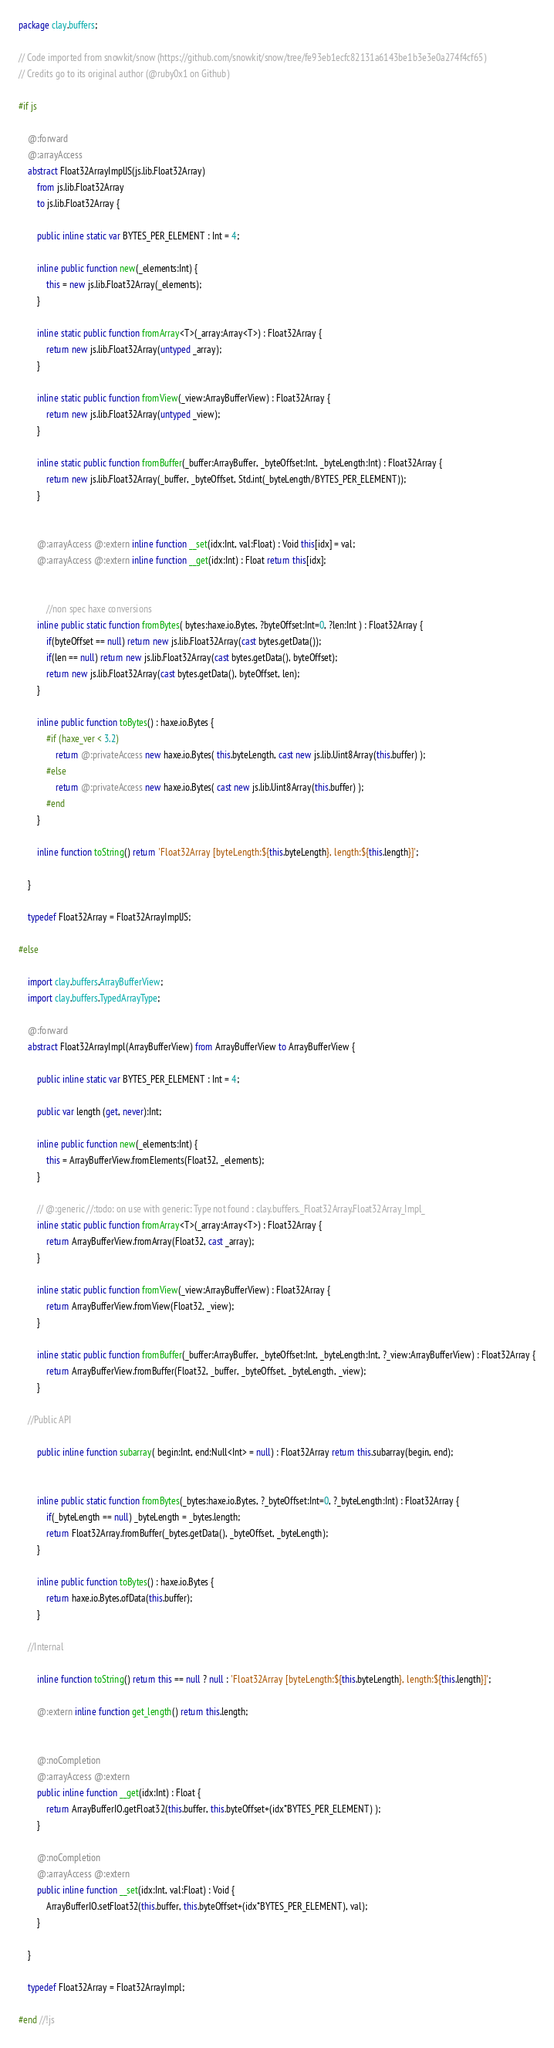<code> <loc_0><loc_0><loc_500><loc_500><_Haxe_>package clay.buffers;

// Code imported from snowkit/snow (https://github.com/snowkit/snow/tree/fe93eb1ecfc82131a6143be1b3e3e0a274f4cf65)
// Credits go to its original author (@ruby0x1 on Github)

#if js

    @:forward
    @:arrayAccess
    abstract Float32ArrayImplJS(js.lib.Float32Array)
        from js.lib.Float32Array
        to js.lib.Float32Array {

        public inline static var BYTES_PER_ELEMENT : Int = 4;

        inline public function new(_elements:Int) {
            this = new js.lib.Float32Array(_elements);
        }

        inline static public function fromArray<T>(_array:Array<T>) : Float32Array {
            return new js.lib.Float32Array(untyped _array);
        }

        inline static public function fromView(_view:ArrayBufferView) : Float32Array {
            return new js.lib.Float32Array(untyped _view);
        }

        inline static public function fromBuffer(_buffer:ArrayBuffer, _byteOffset:Int, _byteLength:Int) : Float32Array {
            return new js.lib.Float32Array(_buffer, _byteOffset, Std.int(_byteLength/BYTES_PER_ELEMENT));
        }


        @:arrayAccess @:extern inline function __set(idx:Int, val:Float) : Void this[idx] = val;
        @:arrayAccess @:extern inline function __get(idx:Int) : Float return this[idx];


            //non spec haxe conversions
        inline public static function fromBytes( bytes:haxe.io.Bytes, ?byteOffset:Int=0, ?len:Int ) : Float32Array {
            if(byteOffset == null) return new js.lib.Float32Array(cast bytes.getData());
            if(len == null) return new js.lib.Float32Array(cast bytes.getData(), byteOffset);
            return new js.lib.Float32Array(cast bytes.getData(), byteOffset, len);
        }

        inline public function toBytes() : haxe.io.Bytes {
            #if (haxe_ver < 3.2)
                return @:privateAccess new haxe.io.Bytes( this.byteLength, cast new js.lib.Uint8Array(this.buffer) );
            #else
                return @:privateAccess new haxe.io.Bytes( cast new js.lib.Uint8Array(this.buffer) );
            #end
        }

        inline function toString() return 'Float32Array [byteLength:${this.byteLength}, length:${this.length}]';

    }

    typedef Float32Array = Float32ArrayImplJS;

#else

    import clay.buffers.ArrayBufferView;
    import clay.buffers.TypedArrayType;

    @:forward
    abstract Float32ArrayImpl(ArrayBufferView) from ArrayBufferView to ArrayBufferView {

        public inline static var BYTES_PER_ELEMENT : Int = 4;

        public var length (get, never):Int;

        inline public function new(_elements:Int) {
            this = ArrayBufferView.fromElements(Float32, _elements);
        }

        // @:generic //:todo: on use with generic: Type not found : clay.buffers._Float32Array.Float32Array_Impl_
        inline static public function fromArray<T>(_array:Array<T>) : Float32Array {
            return ArrayBufferView.fromArray(Float32, cast _array);
        }

        inline static public function fromView(_view:ArrayBufferView) : Float32Array {
            return ArrayBufferView.fromView(Float32, _view);
        }

        inline static public function fromBuffer(_buffer:ArrayBuffer, _byteOffset:Int, _byteLength:Int, ?_view:ArrayBufferView) : Float32Array {
            return ArrayBufferView.fromBuffer(Float32, _buffer, _byteOffset, _byteLength, _view);
        }

    //Public API

        public inline function subarray( begin:Int, end:Null<Int> = null) : Float32Array return this.subarray(begin, end);


        inline public static function fromBytes(_bytes:haxe.io.Bytes, ?_byteOffset:Int=0, ?_byteLength:Int) : Float32Array {
            if(_byteLength == null) _byteLength = _bytes.length;
            return Float32Array.fromBuffer(_bytes.getData(), _byteOffset, _byteLength);
        }

        inline public function toBytes() : haxe.io.Bytes {
            return haxe.io.Bytes.ofData(this.buffer);
        }

    //Internal

        inline function toString() return this == null ? null : 'Float32Array [byteLength:${this.byteLength}, length:${this.length}]';

        @:extern inline function get_length() return this.length;


        @:noCompletion
        @:arrayAccess @:extern
        public inline function __get(idx:Int) : Float {
            return ArrayBufferIO.getFloat32(this.buffer, this.byteOffset+(idx*BYTES_PER_ELEMENT) );
        }

        @:noCompletion
        @:arrayAccess @:extern
        public inline function __set(idx:Int, val:Float) : Void {
            ArrayBufferIO.setFloat32(this.buffer, this.byteOffset+(idx*BYTES_PER_ELEMENT), val);
        }

    }

    typedef Float32Array = Float32ArrayImpl;

#end //!js
</code> 